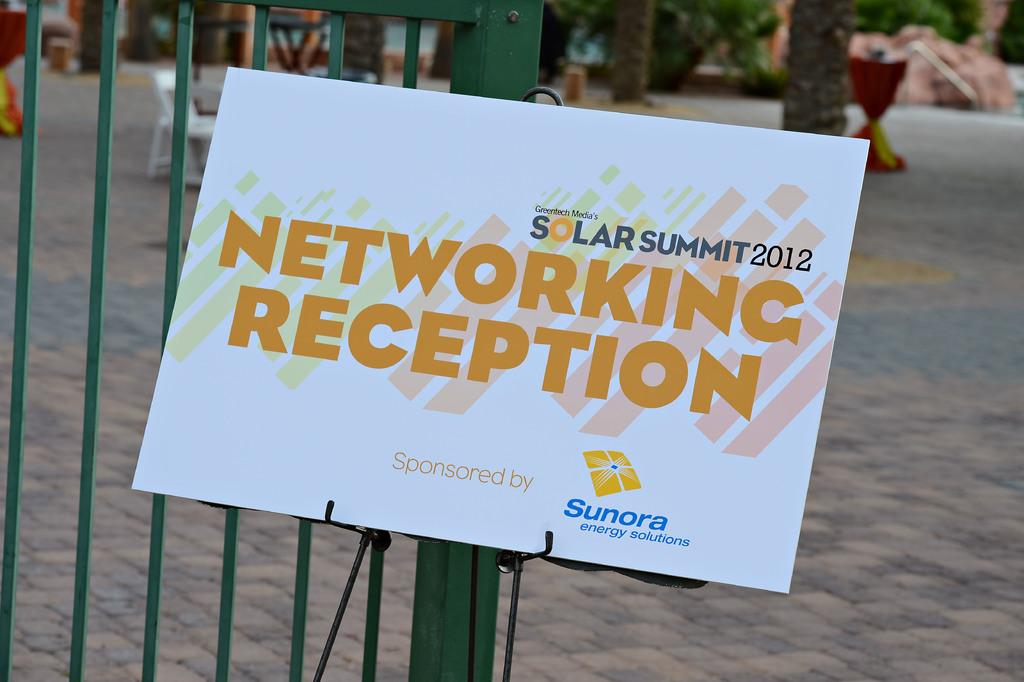What is the main structure visible in the image? There is a gate in the image. What is attached to the gate? A board is attached to the gate. What can be seen in the background of the image? There are trees, chairs, and other objects visible in the background. What is at the bottom of the image? There is a road at the bottom of the image. What type of shoes can be seen on the gate in the image? There are no shoes present on the gate in the image. What scent is associated with the part of the gate that is visible in the image? There is no mention of a scent in the image, and the gate is a physical object, not something that can have a scent. 